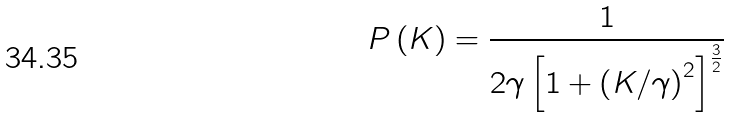Convert formula to latex. <formula><loc_0><loc_0><loc_500><loc_500>P \left ( K \right ) = \frac { 1 } { 2 \gamma \left [ 1 + \left ( K / \gamma \right ) ^ { 2 } \right ] ^ { \frac { 3 } { 2 } } }</formula> 